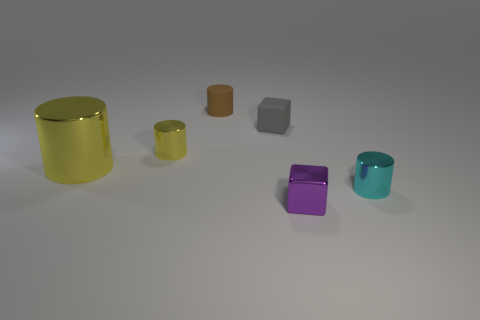Are the objects arranged in any specific pattern? The objects appear to be randomly placed without a discernible pattern, each standing apart from the others. 